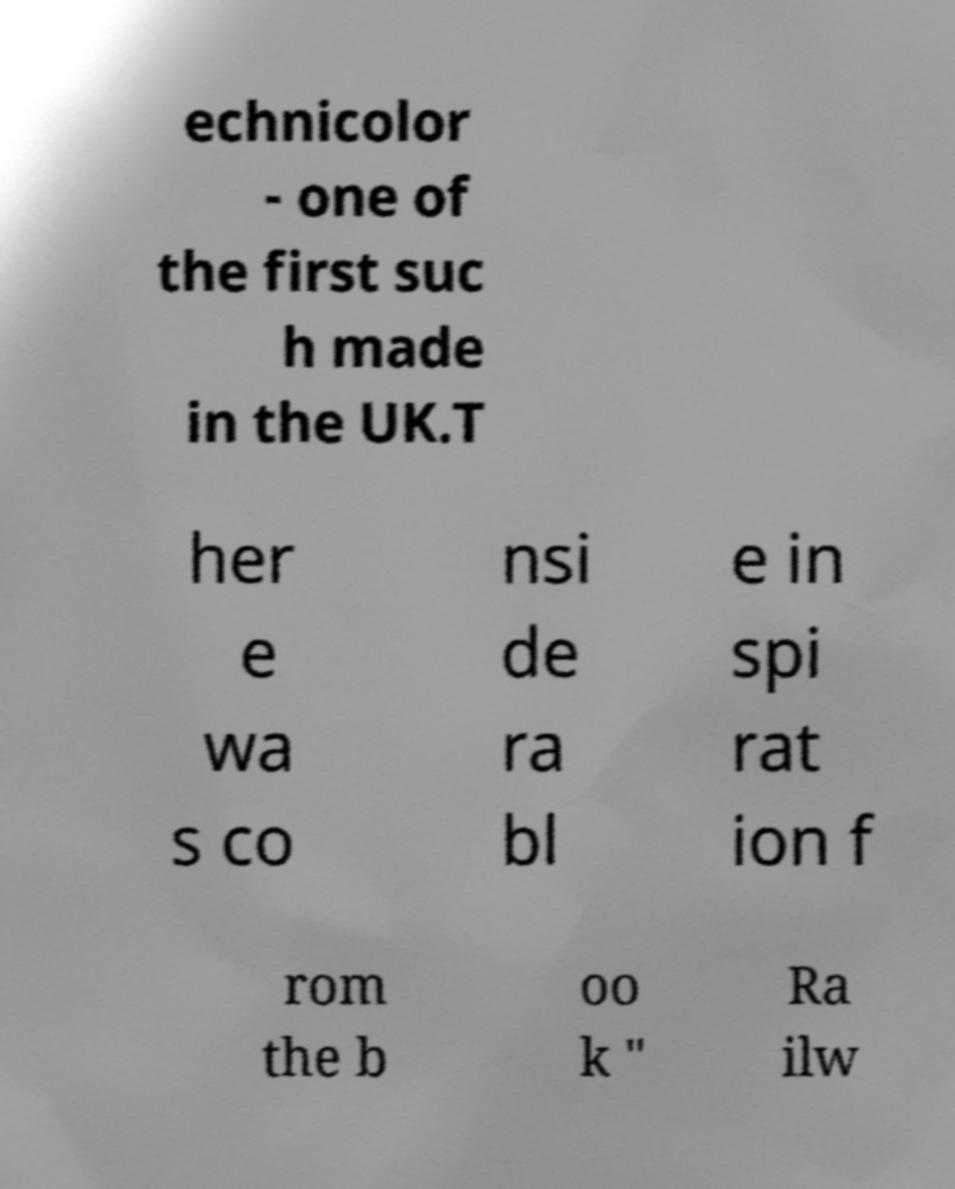Could you extract and type out the text from this image? echnicolor - one of the first suc h made in the UK.T her e wa s co nsi de ra bl e in spi rat ion f rom the b oo k " Ra ilw 